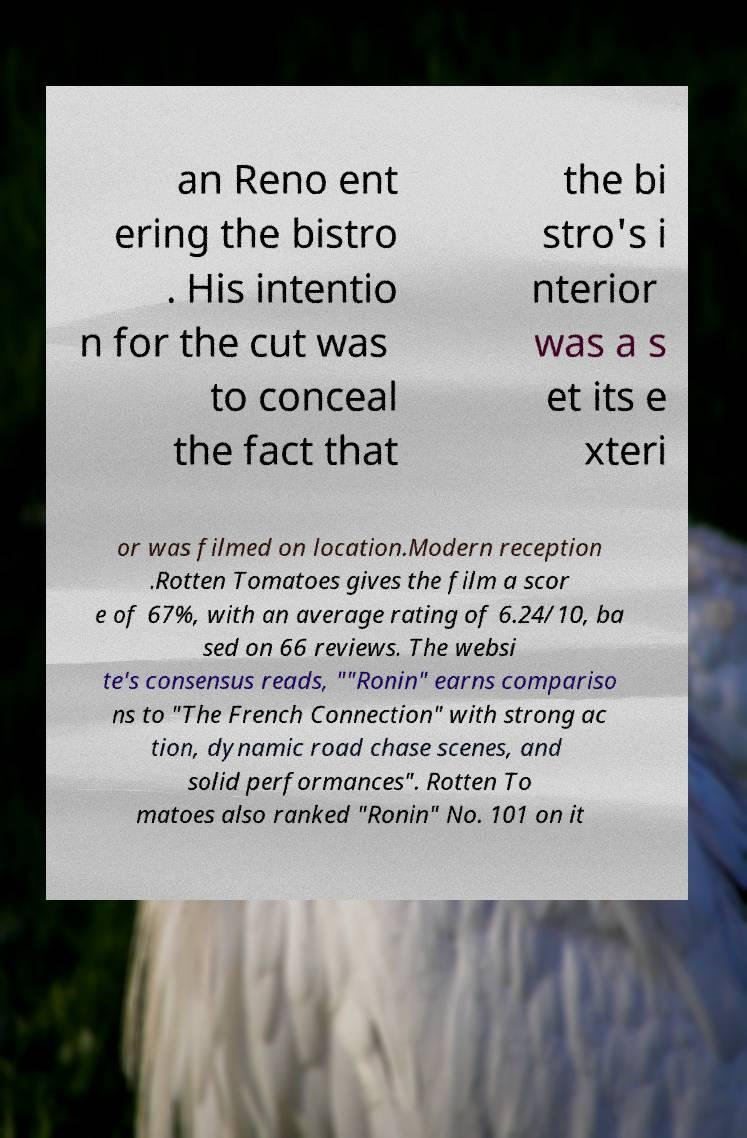There's text embedded in this image that I need extracted. Can you transcribe it verbatim? an Reno ent ering the bistro . His intentio n for the cut was to conceal the fact that the bi stro's i nterior was a s et its e xteri or was filmed on location.Modern reception .Rotten Tomatoes gives the film a scor e of 67%, with an average rating of 6.24/10, ba sed on 66 reviews. The websi te's consensus reads, ""Ronin" earns compariso ns to "The French Connection" with strong ac tion, dynamic road chase scenes, and solid performances". Rotten To matoes also ranked "Ronin" No. 101 on it 